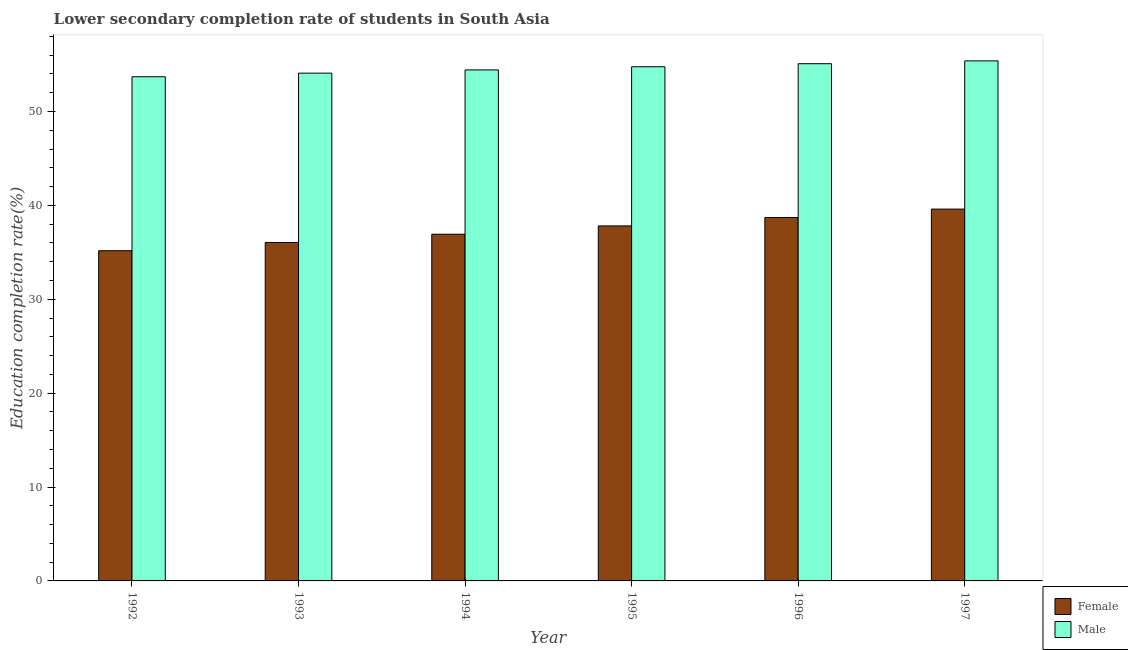How many different coloured bars are there?
Offer a terse response. 2. Are the number of bars per tick equal to the number of legend labels?
Ensure brevity in your answer.  Yes. Are the number of bars on each tick of the X-axis equal?
Ensure brevity in your answer.  Yes. How many bars are there on the 2nd tick from the right?
Offer a terse response. 2. What is the label of the 5th group of bars from the left?
Ensure brevity in your answer.  1996. What is the education completion rate of male students in 1994?
Your answer should be very brief. 54.43. Across all years, what is the maximum education completion rate of male students?
Provide a succinct answer. 55.39. Across all years, what is the minimum education completion rate of female students?
Make the answer very short. 35.17. What is the total education completion rate of male students in the graph?
Ensure brevity in your answer.  327.48. What is the difference between the education completion rate of male students in 1993 and that in 1997?
Offer a terse response. -1.31. What is the difference between the education completion rate of female students in 1994 and the education completion rate of male students in 1992?
Keep it short and to the point. 1.76. What is the average education completion rate of male students per year?
Offer a terse response. 54.58. In how many years, is the education completion rate of male students greater than 16 %?
Offer a terse response. 6. What is the ratio of the education completion rate of female students in 1994 to that in 1997?
Your response must be concise. 0.93. Is the education completion rate of male students in 1992 less than that in 1995?
Your answer should be compact. Yes. Is the difference between the education completion rate of female students in 1994 and 1997 greater than the difference between the education completion rate of male students in 1994 and 1997?
Your answer should be very brief. No. What is the difference between the highest and the second highest education completion rate of female students?
Your response must be concise. 0.9. What is the difference between the highest and the lowest education completion rate of female students?
Provide a succinct answer. 4.43. Is the sum of the education completion rate of male students in 1994 and 1997 greater than the maximum education completion rate of female students across all years?
Give a very brief answer. Yes. What does the 2nd bar from the left in 1992 represents?
Your answer should be compact. Male. What does the 2nd bar from the right in 1997 represents?
Provide a succinct answer. Female. How many bars are there?
Provide a succinct answer. 12. Are all the bars in the graph horizontal?
Your answer should be compact. No. What is the difference between two consecutive major ticks on the Y-axis?
Your answer should be very brief. 10. Does the graph contain grids?
Offer a very short reply. No. Where does the legend appear in the graph?
Make the answer very short. Bottom right. How many legend labels are there?
Your answer should be very brief. 2. What is the title of the graph?
Provide a short and direct response. Lower secondary completion rate of students in South Asia. Does "Domestic Liabilities" appear as one of the legend labels in the graph?
Keep it short and to the point. No. What is the label or title of the X-axis?
Your answer should be compact. Year. What is the label or title of the Y-axis?
Your response must be concise. Education completion rate(%). What is the Education completion rate(%) of Female in 1992?
Offer a terse response. 35.17. What is the Education completion rate(%) of Male in 1992?
Make the answer very short. 53.7. What is the Education completion rate(%) of Female in 1993?
Your answer should be compact. 36.05. What is the Education completion rate(%) in Male in 1993?
Make the answer very short. 54.09. What is the Education completion rate(%) of Female in 1994?
Give a very brief answer. 36.93. What is the Education completion rate(%) in Male in 1994?
Keep it short and to the point. 54.43. What is the Education completion rate(%) in Female in 1995?
Your response must be concise. 37.82. What is the Education completion rate(%) of Male in 1995?
Keep it short and to the point. 54.77. What is the Education completion rate(%) in Female in 1996?
Your answer should be compact. 38.71. What is the Education completion rate(%) in Male in 1996?
Provide a short and direct response. 55.09. What is the Education completion rate(%) of Female in 1997?
Offer a very short reply. 39.61. What is the Education completion rate(%) of Male in 1997?
Give a very brief answer. 55.39. Across all years, what is the maximum Education completion rate(%) in Female?
Offer a terse response. 39.61. Across all years, what is the maximum Education completion rate(%) in Male?
Give a very brief answer. 55.39. Across all years, what is the minimum Education completion rate(%) of Female?
Your response must be concise. 35.17. Across all years, what is the minimum Education completion rate(%) of Male?
Make the answer very short. 53.7. What is the total Education completion rate(%) of Female in the graph?
Provide a short and direct response. 224.29. What is the total Education completion rate(%) in Male in the graph?
Make the answer very short. 327.48. What is the difference between the Education completion rate(%) of Female in 1992 and that in 1993?
Offer a terse response. -0.88. What is the difference between the Education completion rate(%) of Male in 1992 and that in 1993?
Provide a succinct answer. -0.38. What is the difference between the Education completion rate(%) in Female in 1992 and that in 1994?
Offer a very short reply. -1.76. What is the difference between the Education completion rate(%) in Male in 1992 and that in 1994?
Ensure brevity in your answer.  -0.73. What is the difference between the Education completion rate(%) in Female in 1992 and that in 1995?
Offer a terse response. -2.64. What is the difference between the Education completion rate(%) in Male in 1992 and that in 1995?
Ensure brevity in your answer.  -1.07. What is the difference between the Education completion rate(%) of Female in 1992 and that in 1996?
Make the answer very short. -3.54. What is the difference between the Education completion rate(%) of Male in 1992 and that in 1996?
Provide a short and direct response. -1.39. What is the difference between the Education completion rate(%) in Female in 1992 and that in 1997?
Keep it short and to the point. -4.43. What is the difference between the Education completion rate(%) of Male in 1992 and that in 1997?
Your answer should be very brief. -1.69. What is the difference between the Education completion rate(%) in Female in 1993 and that in 1994?
Your answer should be very brief. -0.88. What is the difference between the Education completion rate(%) of Male in 1993 and that in 1994?
Your response must be concise. -0.35. What is the difference between the Education completion rate(%) in Female in 1993 and that in 1995?
Give a very brief answer. -1.76. What is the difference between the Education completion rate(%) of Male in 1993 and that in 1995?
Your response must be concise. -0.68. What is the difference between the Education completion rate(%) of Female in 1993 and that in 1996?
Your answer should be very brief. -2.66. What is the difference between the Education completion rate(%) of Male in 1993 and that in 1996?
Your response must be concise. -1.01. What is the difference between the Education completion rate(%) of Female in 1993 and that in 1997?
Your answer should be compact. -3.55. What is the difference between the Education completion rate(%) of Male in 1993 and that in 1997?
Offer a very short reply. -1.31. What is the difference between the Education completion rate(%) of Female in 1994 and that in 1995?
Ensure brevity in your answer.  -0.89. What is the difference between the Education completion rate(%) of Male in 1994 and that in 1995?
Make the answer very short. -0.34. What is the difference between the Education completion rate(%) of Female in 1994 and that in 1996?
Your answer should be compact. -1.78. What is the difference between the Education completion rate(%) in Male in 1994 and that in 1996?
Offer a terse response. -0.66. What is the difference between the Education completion rate(%) in Female in 1994 and that in 1997?
Keep it short and to the point. -2.68. What is the difference between the Education completion rate(%) of Male in 1994 and that in 1997?
Ensure brevity in your answer.  -0.96. What is the difference between the Education completion rate(%) of Female in 1995 and that in 1996?
Keep it short and to the point. -0.89. What is the difference between the Education completion rate(%) of Male in 1995 and that in 1996?
Give a very brief answer. -0.32. What is the difference between the Education completion rate(%) of Female in 1995 and that in 1997?
Offer a terse response. -1.79. What is the difference between the Education completion rate(%) in Male in 1995 and that in 1997?
Provide a succinct answer. -0.62. What is the difference between the Education completion rate(%) in Female in 1996 and that in 1997?
Provide a succinct answer. -0.9. What is the difference between the Education completion rate(%) in Male in 1996 and that in 1997?
Offer a terse response. -0.3. What is the difference between the Education completion rate(%) of Female in 1992 and the Education completion rate(%) of Male in 1993?
Offer a very short reply. -18.91. What is the difference between the Education completion rate(%) of Female in 1992 and the Education completion rate(%) of Male in 1994?
Offer a terse response. -19.26. What is the difference between the Education completion rate(%) in Female in 1992 and the Education completion rate(%) in Male in 1995?
Give a very brief answer. -19.6. What is the difference between the Education completion rate(%) in Female in 1992 and the Education completion rate(%) in Male in 1996?
Keep it short and to the point. -19.92. What is the difference between the Education completion rate(%) of Female in 1992 and the Education completion rate(%) of Male in 1997?
Give a very brief answer. -20.22. What is the difference between the Education completion rate(%) in Female in 1993 and the Education completion rate(%) in Male in 1994?
Make the answer very short. -18.38. What is the difference between the Education completion rate(%) in Female in 1993 and the Education completion rate(%) in Male in 1995?
Your answer should be very brief. -18.72. What is the difference between the Education completion rate(%) in Female in 1993 and the Education completion rate(%) in Male in 1996?
Your answer should be very brief. -19.04. What is the difference between the Education completion rate(%) in Female in 1993 and the Education completion rate(%) in Male in 1997?
Give a very brief answer. -19.34. What is the difference between the Education completion rate(%) in Female in 1994 and the Education completion rate(%) in Male in 1995?
Keep it short and to the point. -17.84. What is the difference between the Education completion rate(%) of Female in 1994 and the Education completion rate(%) of Male in 1996?
Keep it short and to the point. -18.16. What is the difference between the Education completion rate(%) in Female in 1994 and the Education completion rate(%) in Male in 1997?
Provide a short and direct response. -18.46. What is the difference between the Education completion rate(%) of Female in 1995 and the Education completion rate(%) of Male in 1996?
Provide a succinct answer. -17.28. What is the difference between the Education completion rate(%) of Female in 1995 and the Education completion rate(%) of Male in 1997?
Your answer should be very brief. -17.58. What is the difference between the Education completion rate(%) of Female in 1996 and the Education completion rate(%) of Male in 1997?
Offer a terse response. -16.69. What is the average Education completion rate(%) in Female per year?
Offer a terse response. 37.38. What is the average Education completion rate(%) of Male per year?
Provide a short and direct response. 54.58. In the year 1992, what is the difference between the Education completion rate(%) of Female and Education completion rate(%) of Male?
Offer a terse response. -18.53. In the year 1993, what is the difference between the Education completion rate(%) in Female and Education completion rate(%) in Male?
Your response must be concise. -18.03. In the year 1994, what is the difference between the Education completion rate(%) in Female and Education completion rate(%) in Male?
Keep it short and to the point. -17.5. In the year 1995, what is the difference between the Education completion rate(%) in Female and Education completion rate(%) in Male?
Your answer should be very brief. -16.95. In the year 1996, what is the difference between the Education completion rate(%) in Female and Education completion rate(%) in Male?
Keep it short and to the point. -16.38. In the year 1997, what is the difference between the Education completion rate(%) in Female and Education completion rate(%) in Male?
Provide a succinct answer. -15.79. What is the ratio of the Education completion rate(%) of Female in 1992 to that in 1993?
Provide a short and direct response. 0.98. What is the ratio of the Education completion rate(%) in Male in 1992 to that in 1993?
Offer a terse response. 0.99. What is the ratio of the Education completion rate(%) in Male in 1992 to that in 1994?
Your response must be concise. 0.99. What is the ratio of the Education completion rate(%) of Female in 1992 to that in 1995?
Your answer should be very brief. 0.93. What is the ratio of the Education completion rate(%) in Male in 1992 to that in 1995?
Your answer should be very brief. 0.98. What is the ratio of the Education completion rate(%) in Female in 1992 to that in 1996?
Offer a terse response. 0.91. What is the ratio of the Education completion rate(%) in Male in 1992 to that in 1996?
Offer a terse response. 0.97. What is the ratio of the Education completion rate(%) of Female in 1992 to that in 1997?
Your answer should be compact. 0.89. What is the ratio of the Education completion rate(%) in Male in 1992 to that in 1997?
Offer a terse response. 0.97. What is the ratio of the Education completion rate(%) of Female in 1993 to that in 1994?
Make the answer very short. 0.98. What is the ratio of the Education completion rate(%) in Male in 1993 to that in 1994?
Provide a short and direct response. 0.99. What is the ratio of the Education completion rate(%) in Female in 1993 to that in 1995?
Your response must be concise. 0.95. What is the ratio of the Education completion rate(%) of Male in 1993 to that in 1995?
Your answer should be very brief. 0.99. What is the ratio of the Education completion rate(%) of Female in 1993 to that in 1996?
Keep it short and to the point. 0.93. What is the ratio of the Education completion rate(%) in Male in 1993 to that in 1996?
Keep it short and to the point. 0.98. What is the ratio of the Education completion rate(%) in Female in 1993 to that in 1997?
Make the answer very short. 0.91. What is the ratio of the Education completion rate(%) of Male in 1993 to that in 1997?
Provide a succinct answer. 0.98. What is the ratio of the Education completion rate(%) in Female in 1994 to that in 1995?
Your answer should be compact. 0.98. What is the ratio of the Education completion rate(%) in Female in 1994 to that in 1996?
Provide a short and direct response. 0.95. What is the ratio of the Education completion rate(%) of Female in 1994 to that in 1997?
Ensure brevity in your answer.  0.93. What is the ratio of the Education completion rate(%) in Male in 1994 to that in 1997?
Provide a succinct answer. 0.98. What is the ratio of the Education completion rate(%) in Female in 1995 to that in 1996?
Offer a terse response. 0.98. What is the ratio of the Education completion rate(%) of Female in 1995 to that in 1997?
Give a very brief answer. 0.95. What is the ratio of the Education completion rate(%) of Male in 1995 to that in 1997?
Provide a short and direct response. 0.99. What is the ratio of the Education completion rate(%) in Female in 1996 to that in 1997?
Keep it short and to the point. 0.98. What is the difference between the highest and the second highest Education completion rate(%) in Female?
Ensure brevity in your answer.  0.9. What is the difference between the highest and the second highest Education completion rate(%) in Male?
Your response must be concise. 0.3. What is the difference between the highest and the lowest Education completion rate(%) of Female?
Your answer should be very brief. 4.43. What is the difference between the highest and the lowest Education completion rate(%) in Male?
Offer a terse response. 1.69. 